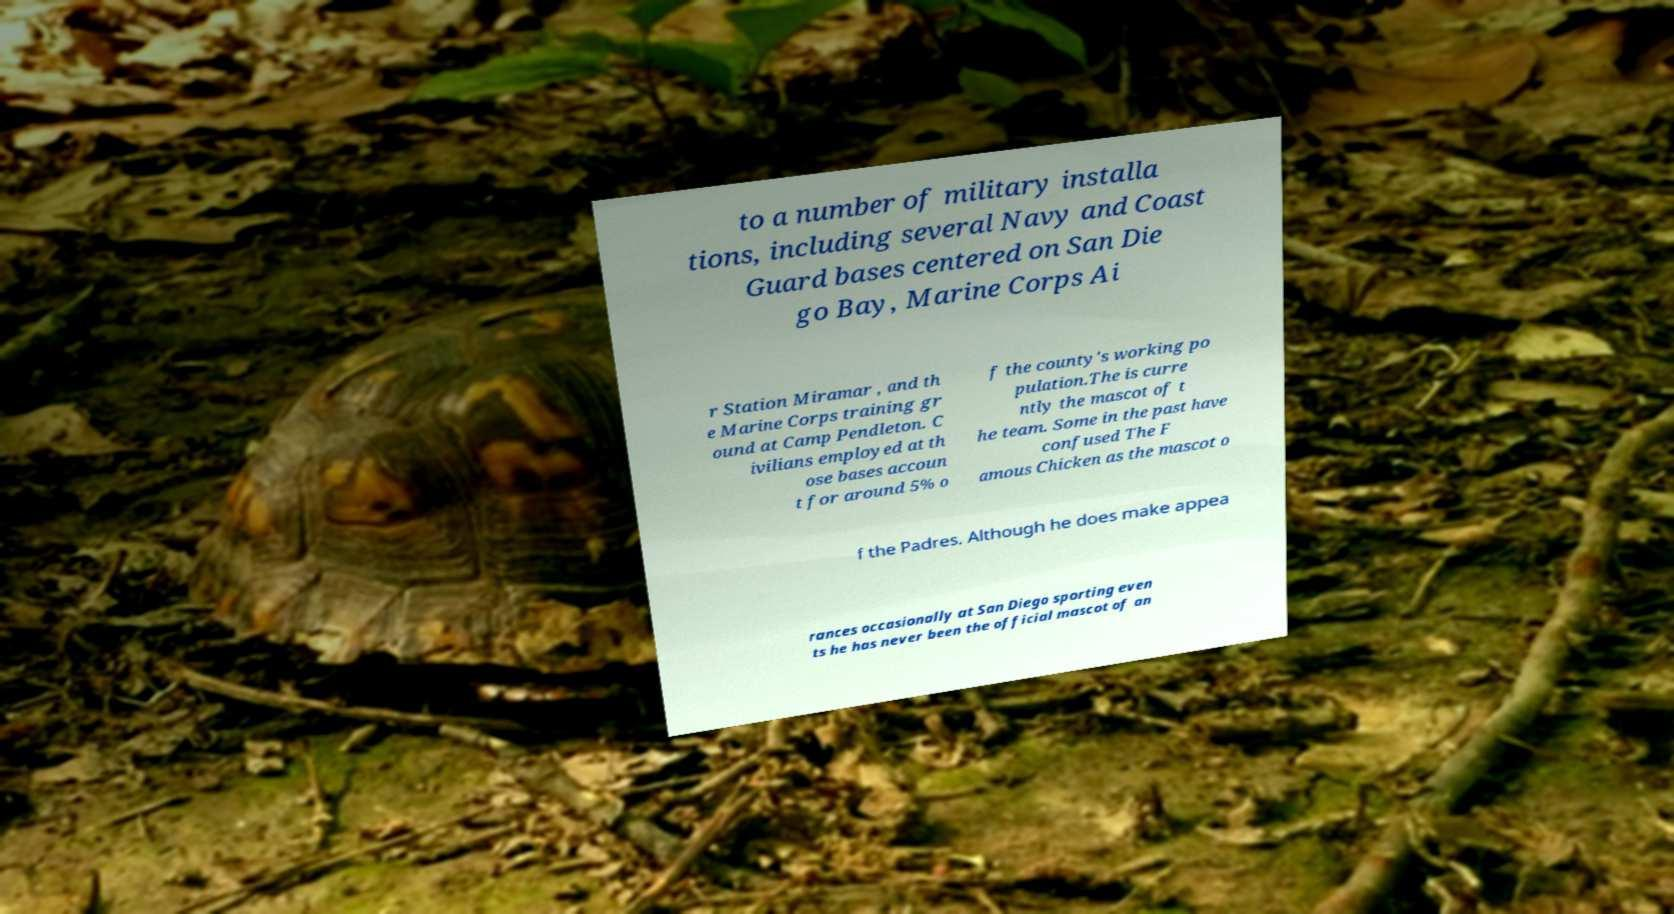What messages or text are displayed in this image? I need them in a readable, typed format. to a number of military installa tions, including several Navy and Coast Guard bases centered on San Die go Bay, Marine Corps Ai r Station Miramar , and th e Marine Corps training gr ound at Camp Pendleton. C ivilians employed at th ose bases accoun t for around 5% o f the county's working po pulation.The is curre ntly the mascot of t he team. Some in the past have confused The F amous Chicken as the mascot o f the Padres. Although he does make appea rances occasionally at San Diego sporting even ts he has never been the official mascot of an 